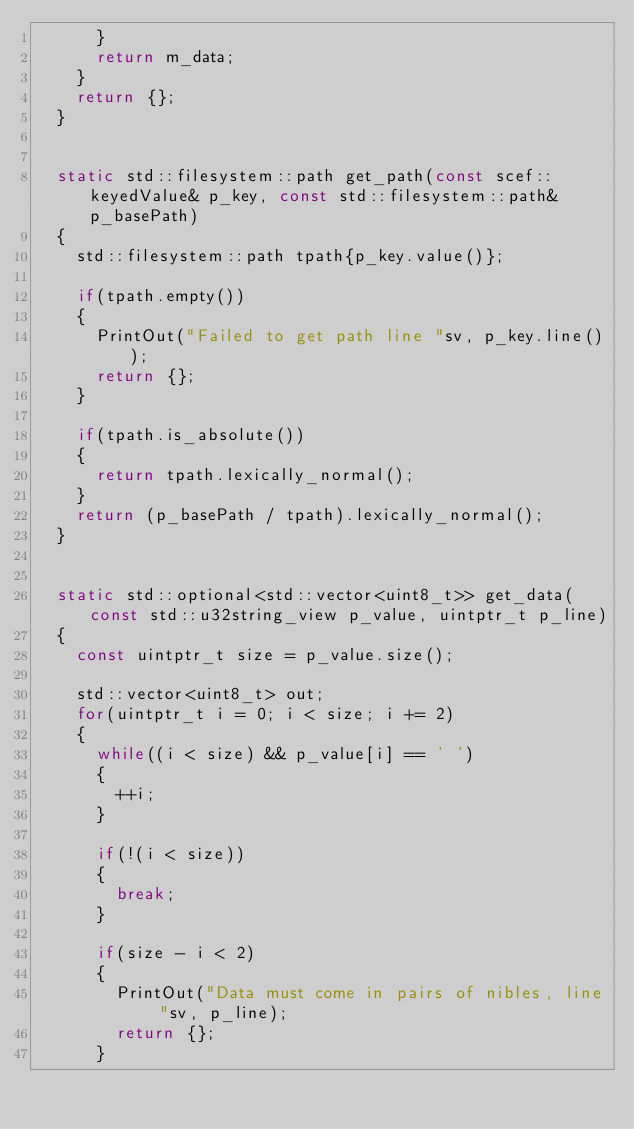Convert code to text. <code><loc_0><loc_0><loc_500><loc_500><_C++_>			}
			return m_data;
		}
		return {};
	}


	static std::filesystem::path get_path(const scef::keyedValue& p_key, const std::filesystem::path& p_basePath)
	{
		std::filesystem::path tpath{p_key.value()};

		if(tpath.empty())
		{
			PrintOut("Failed to get path line "sv, p_key.line());
			return {};
		}

		if(tpath.is_absolute())
		{
			return tpath.lexically_normal();
		}
		return (p_basePath / tpath).lexically_normal();
	}


	static std::optional<std::vector<uint8_t>> get_data(const std::u32string_view p_value, uintptr_t p_line)
	{
		const uintptr_t size = p_value.size();

		std::vector<uint8_t> out;
		for(uintptr_t i = 0; i < size; i += 2)
		{
			while((i < size) && p_value[i] == ' ')
			{
				++i;
			}

			if(!(i < size))
			{
				break;
			}

			if(size - i < 2)
			{
				PrintOut("Data must come in pairs of nibles, line "sv, p_line);
				return {};
			}
</code> 